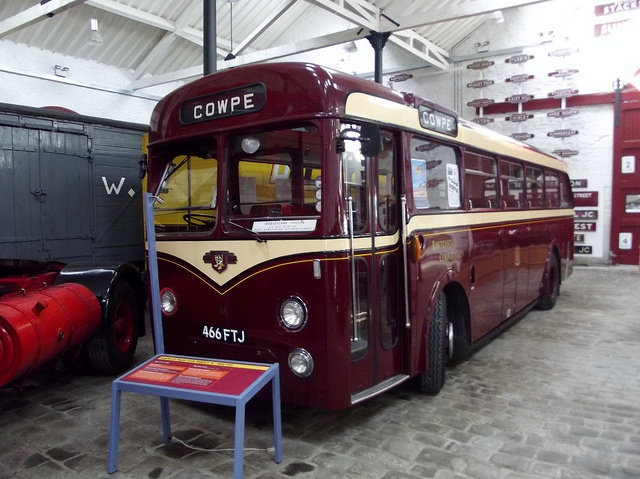Describe the objects in this image and their specific colors. I can see bus in gray, black, maroon, and ivory tones and truck in gray, black, and darkblue tones in this image. 